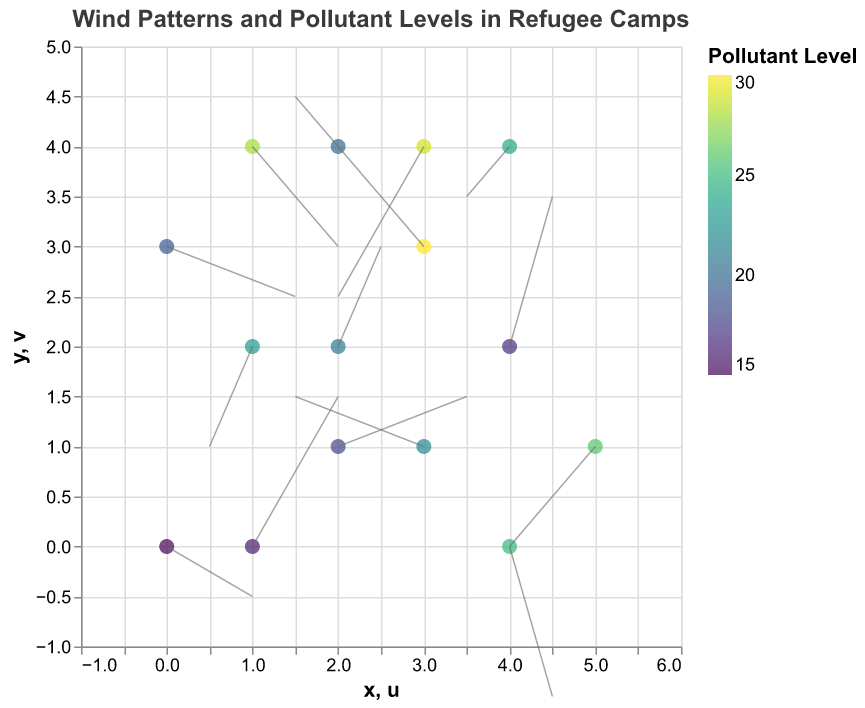What's the title of the figure? The title is displayed prominently at the top of the figure.
Answer: Wind Patterns and Pollutant Levels in Refugee Camps What are the axes labels used in the figure? The axes labels are visible on the horizontal and vertical axes of the figure.
Answer: X and Y What color scheme is used to denote pollutant levels? The figure uses a color gradient to indicate different pollutant levels. According to the code, the "viridis" color scheme is applied.
Answer: Viridis How many data points are plotted in the figure? Counting the number of data entries provided in the data table will give the total number of points.
Answer: 15 Which data point has the highest pollutant level, and what is its value? By observing the color gradient and checking the tooltip information, the point with the highest value (32) can be identified.
Answer: (3, 3) with 30 What is the direction and magnitude of the wind vector at position (2, 4)? The direction is indicated by the quiver arrow, and the magnitude can be found using the components u and v.
Answer: Direction: (-1, 1) Which data point has the lowest pollutant level? By examining the color gradient and tooltip data, identify the point with the smallest pollutant value, 15, on the plot.
Answer: (0, 0) with 15 What's the average pollutant level of all the data points? Sum all the pollutant levels and divide by the number of data points. Calculate: (15 + 23 + 18 + 30 + 25 + 20 + 28 + 22 + 17 + 19 + 26 + 21 + 24 + 16 + 29) / 15 = 22.8
Answer: 22.8 Which point has the most significant downward air current? The downward air current is indicated by the largest negative v component in the quiver plot.
Answer: (4, 0) with vector (1, -3) Is there a relationship between wind patterns and pollutant levels in the refugee camps? Assessing the plot visually can reveal if areas with certain wind patterns tend to have higher/lower pollutant levels but requires deeper analysis to confirm. Observing the plot might indicate clustering or spread behavior correlated with wind patterns.
Answer: Shows potential correlation but needs further analysis 